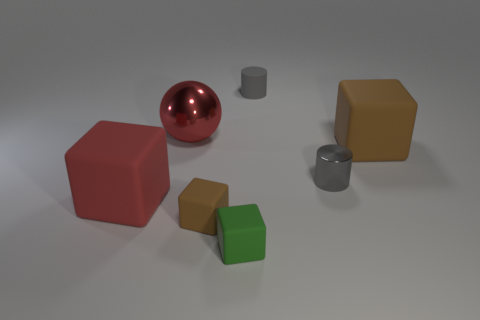What number of balls are red rubber objects or small gray things? In the image, there is one red rubber ball and two small gray objects which appear to be cylindrical in shape. Therefore, combining these, there are three items that either are red rubber objects or small gray things. 